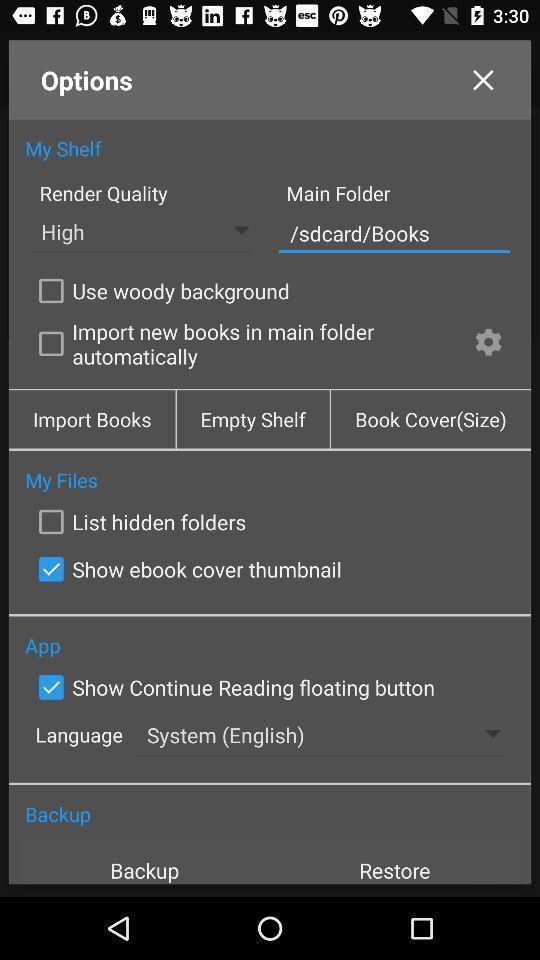Describe this image in words. Setting page of options for an app. 